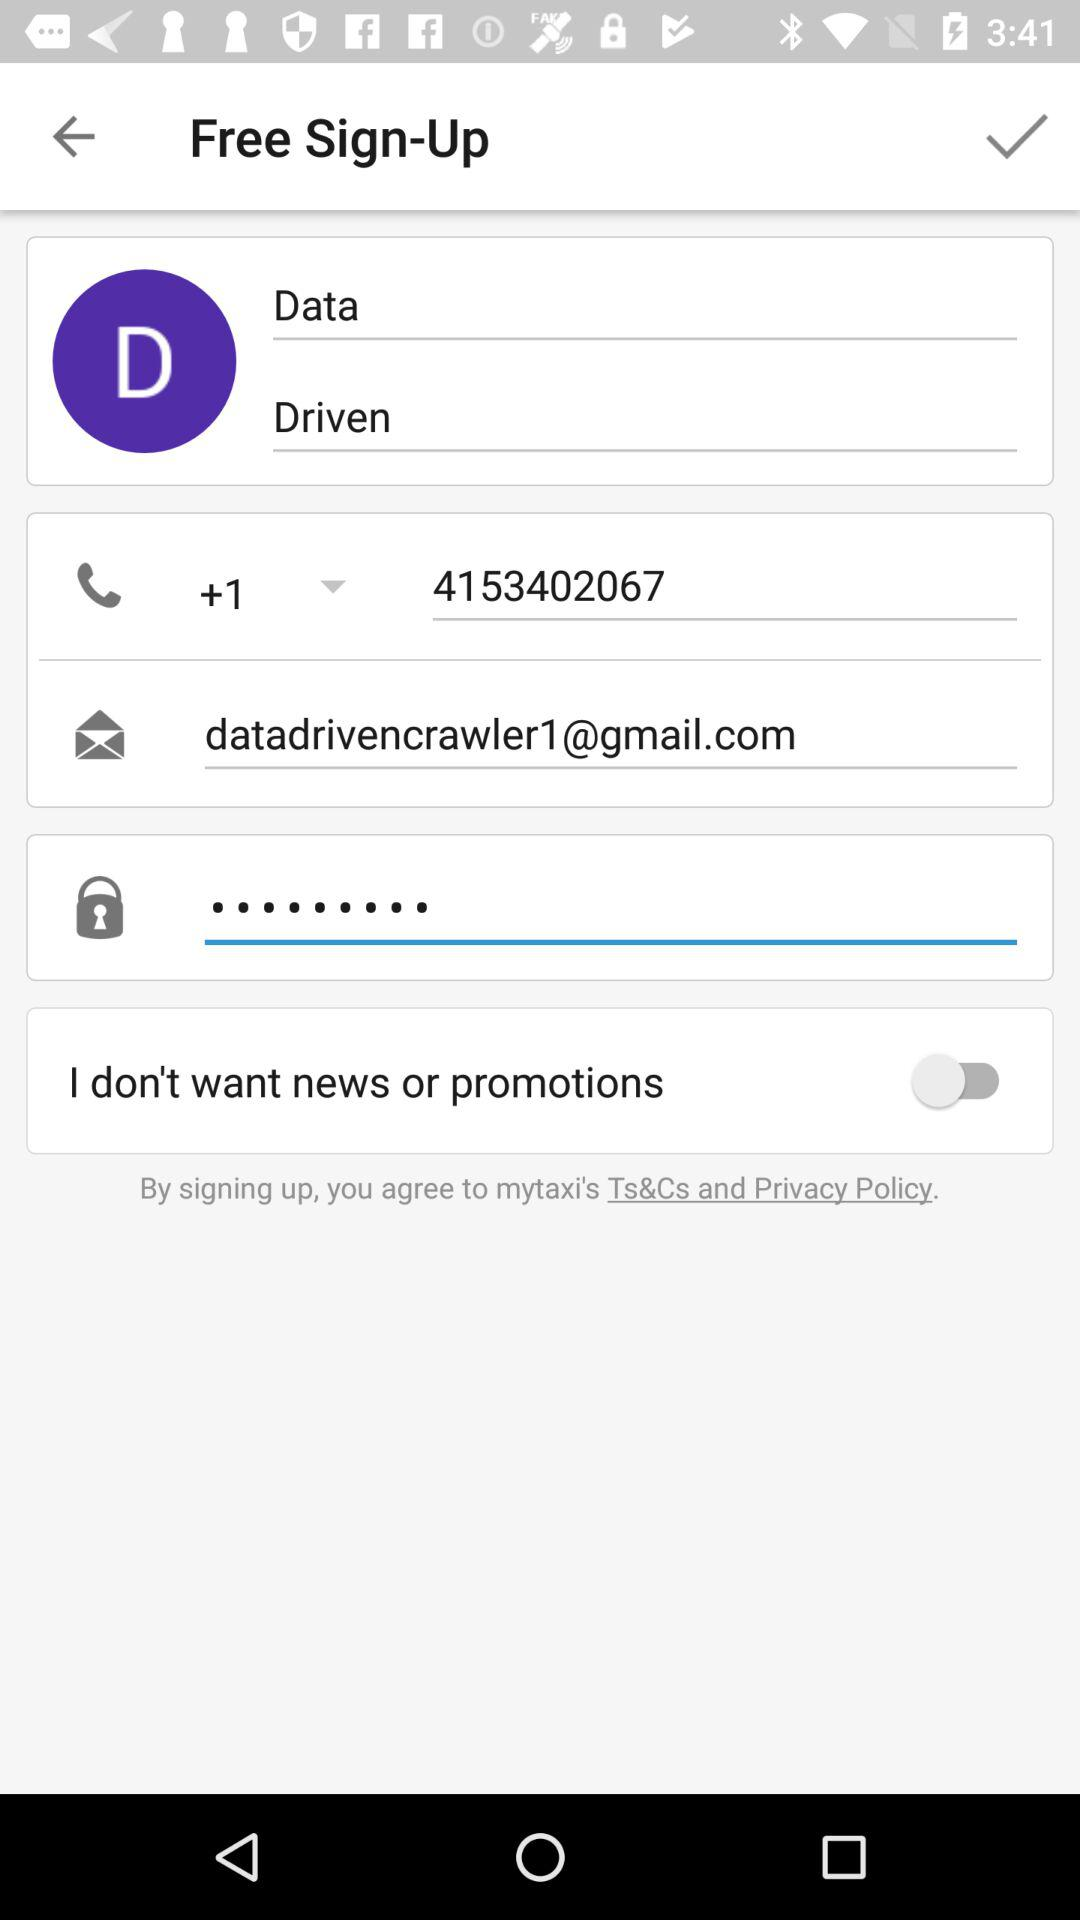What is the email address of the user? The email address of the user is datadrivencrawler1@gmail.com. 